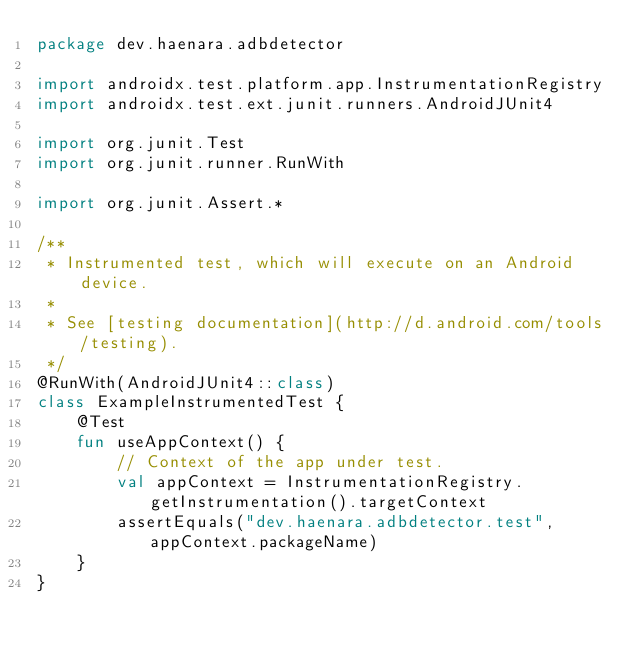Convert code to text. <code><loc_0><loc_0><loc_500><loc_500><_Kotlin_>package dev.haenara.adbdetector

import androidx.test.platform.app.InstrumentationRegistry
import androidx.test.ext.junit.runners.AndroidJUnit4

import org.junit.Test
import org.junit.runner.RunWith

import org.junit.Assert.*

/**
 * Instrumented test, which will execute on an Android device.
 *
 * See [testing documentation](http://d.android.com/tools/testing).
 */
@RunWith(AndroidJUnit4::class)
class ExampleInstrumentedTest {
    @Test
    fun useAppContext() {
        // Context of the app under test.
        val appContext = InstrumentationRegistry.getInstrumentation().targetContext
        assertEquals("dev.haenara.adbdetector.test", appContext.packageName)
    }
}
</code> 